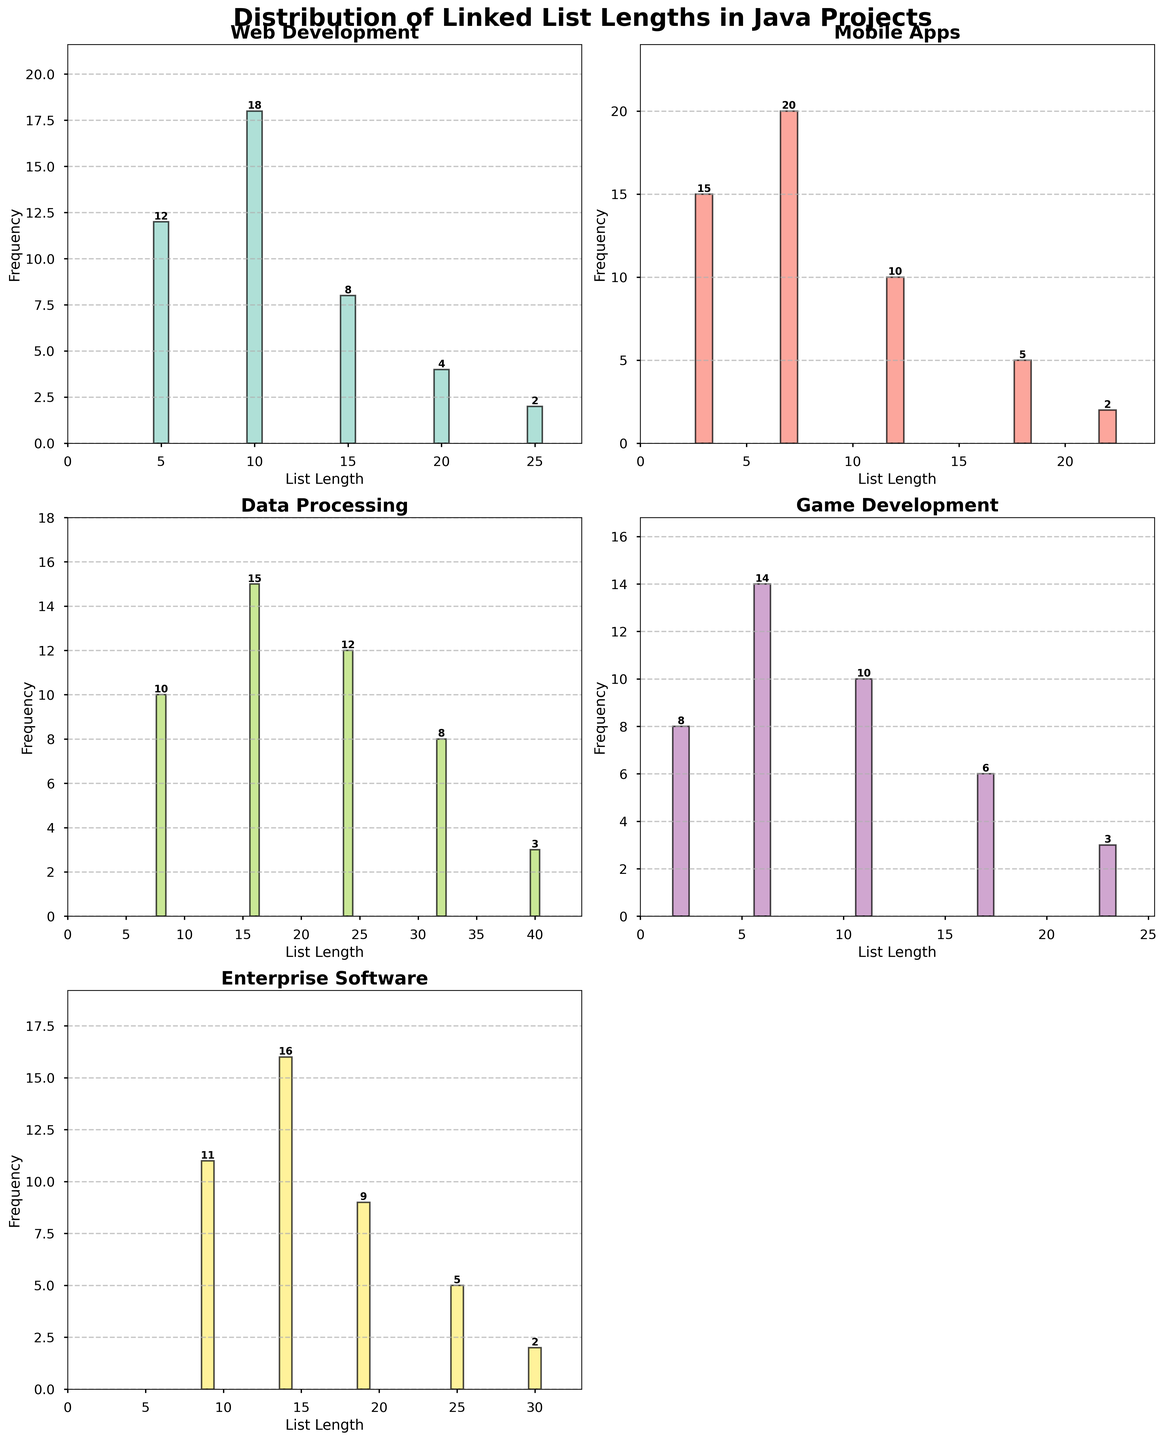What is the title of the figure? The title of the figure is clearly written at the top of the plot.
Answer: Distribution of Linked List Lengths in Java Projects What is the most common list length in the Web Development domain? In the subplot for Web Development, the bar corresponding to list length 10 is the highest.
Answer: 10 How many subplots are there in total? The figure has a 3x2 grid layout, so it should have 6 subplots, but one is empty as shown by the 'off' axis label.
Answer: 5 Which application domain has the lowest maximum list length? The subplot for Mobile Apps has the highest list length reaching only 22.
Answer: Mobile Apps What is the combined frequency of list lengths of 25 in Web Development and 25 in Enterprise Software? The frequency for the list length of 25 in Web Development is 2 and in Enterprise Software it is 5. Adding them together, 2 + 5 = 7.
Answer: 7 Which domain shows a smooth decrease in frequency as the list length increases? Observing the subplots, Web Development shows a smooth decrease in frequencies as the list length increases.
Answer: Web Development How does the frequency of the list length 16 in Data Processing compare to the list length 15 in Web Development? In Data Processing, the frequency of the list length 16 is 15. In Web Development, the frequency of the list length 15 is 8, so 15 is greater than 8.
Answer: Greater Which domain has the highest frequency for any list length, and what is that frequency? Looking at all the subplots, Mobile Apps have the highest frequency bar with a height of 20 for list length 7.
Answer: Mobile Apps, 20 